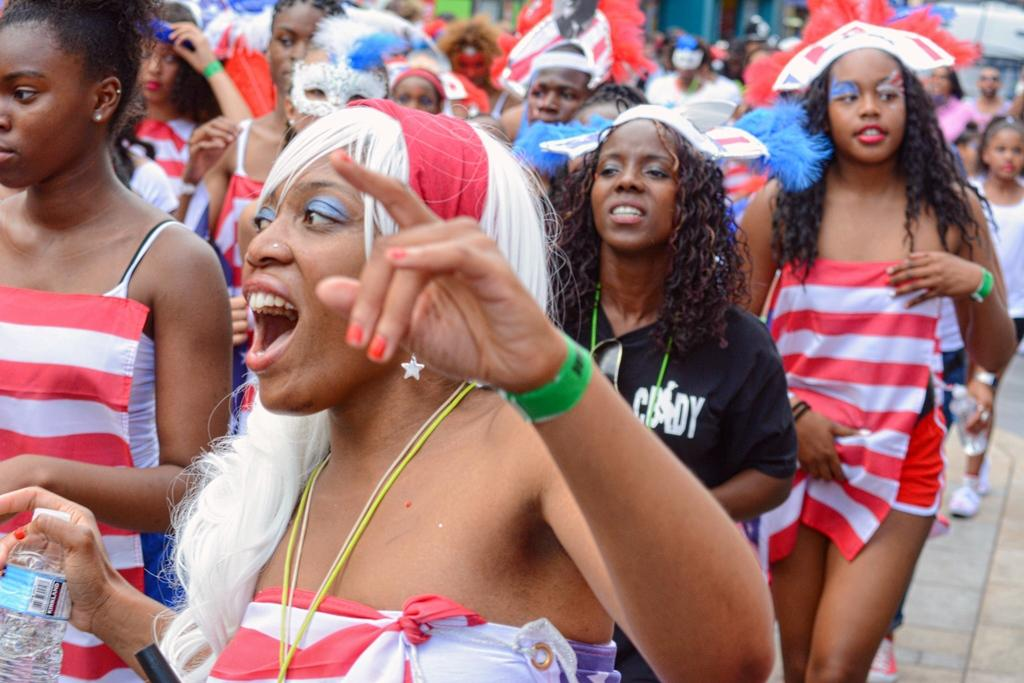How many persons are in the image? There are persons in the image. What colors are the dresses of the persons in the image? The persons are wearing white, red, and black colored dresses. Where are the persons standing in the image? The persons are standing on the ground. Can you describe the background of the image? The background of the image is blurry. What type of paste is being used by the persons in the image? There is no paste present in the image. What note is being played by the persons in the image? There is no musical instrument or note being played by the persons in the image. 